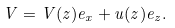<formula> <loc_0><loc_0><loc_500><loc_500>V = V ( z ) e _ { x } + u ( z ) e _ { z } .</formula> 